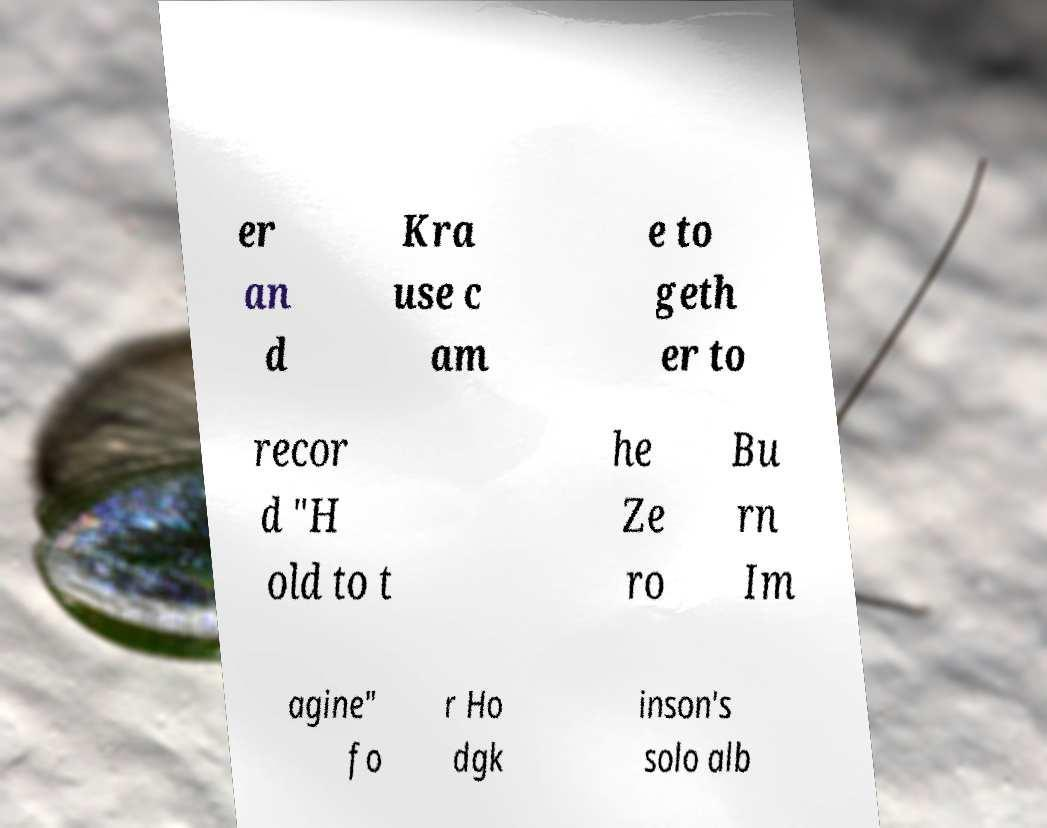I need the written content from this picture converted into text. Can you do that? er an d Kra use c am e to geth er to recor d "H old to t he Ze ro Bu rn Im agine" fo r Ho dgk inson's solo alb 